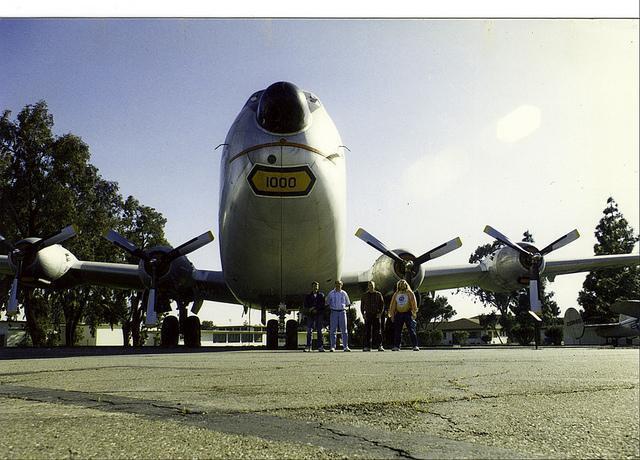How many propellers are on the plane?
Give a very brief answer. 4. How many cats are on the car?
Give a very brief answer. 0. 